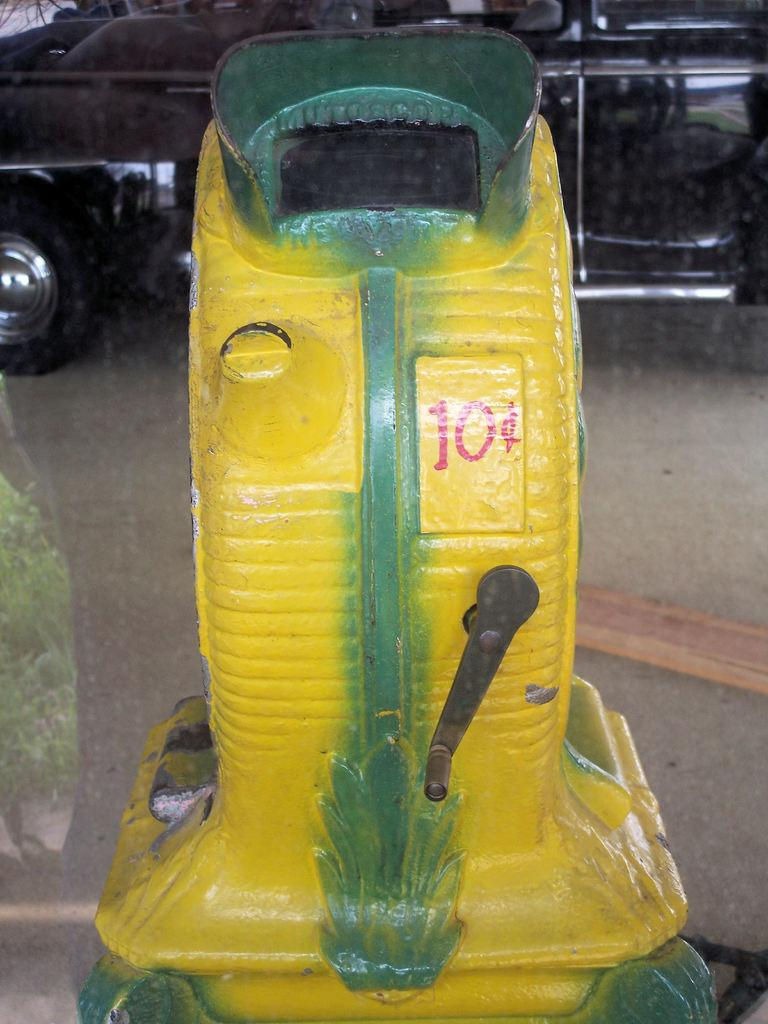What type of machine is in the image? There is an iron machine in the image. What color is the iron machine? The iron machine is yellow in color. Is there any number on the iron machine? Yes, there is a number on the iron machine. What else can be seen in the image besides the iron machine? There is a black color car in the image. Where is the car located in relation to the iron machine? The car is behind the iron machine. How many oranges are on the iron machine in the image? There are no oranges present in the image. What is the title of the image? The image does not have a title. 